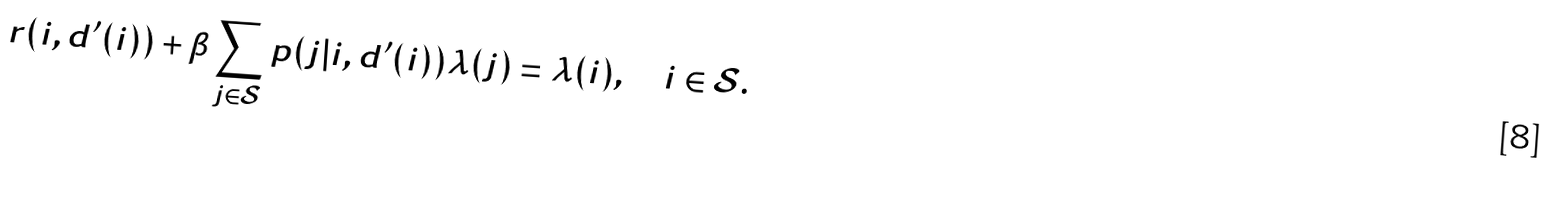Convert formula to latex. <formula><loc_0><loc_0><loc_500><loc_500>r ( i , d ^ { \prime } ( i ) ) + \beta \sum _ { j \in \mathcal { S } } p ( j | i , d ^ { \prime } ( i ) ) \lambda ( j ) = \lambda ( i ) , \quad i \in \mathcal { S } .</formula> 